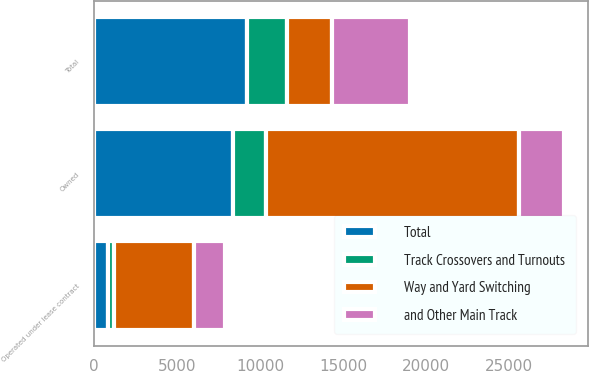Convert chart to OTSL. <chart><loc_0><loc_0><loc_500><loc_500><stacked_bar_chart><ecel><fcel>Owned<fcel>Operated under lease contract<fcel>Total<nl><fcel>Way and Yard Switching<fcel>15194<fcel>4768<fcel>2754<nl><fcel>and Other Main Track<fcel>2754<fcel>1916<fcel>4670<nl><fcel>Track Crossovers and Turnouts<fcel>1976<fcel>398<fcel>2374<nl><fcel>Total<fcel>8381<fcel>834<fcel>9215<nl></chart> 